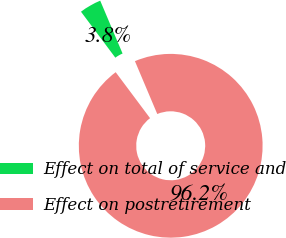<chart> <loc_0><loc_0><loc_500><loc_500><pie_chart><fcel>Effect on total of service and<fcel>Effect on postretirement<nl><fcel>3.85%<fcel>96.15%<nl></chart> 